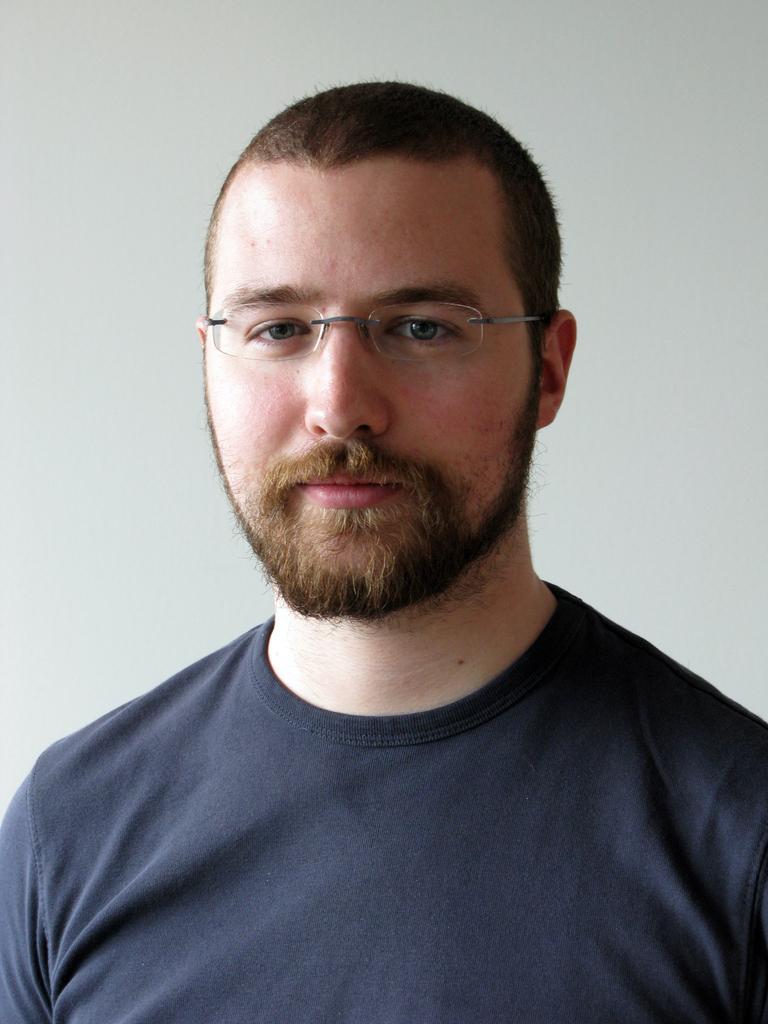Could you give a brief overview of what you see in this image? In this picture we can see a man with the spectacles. Behind the man there is the white background. 